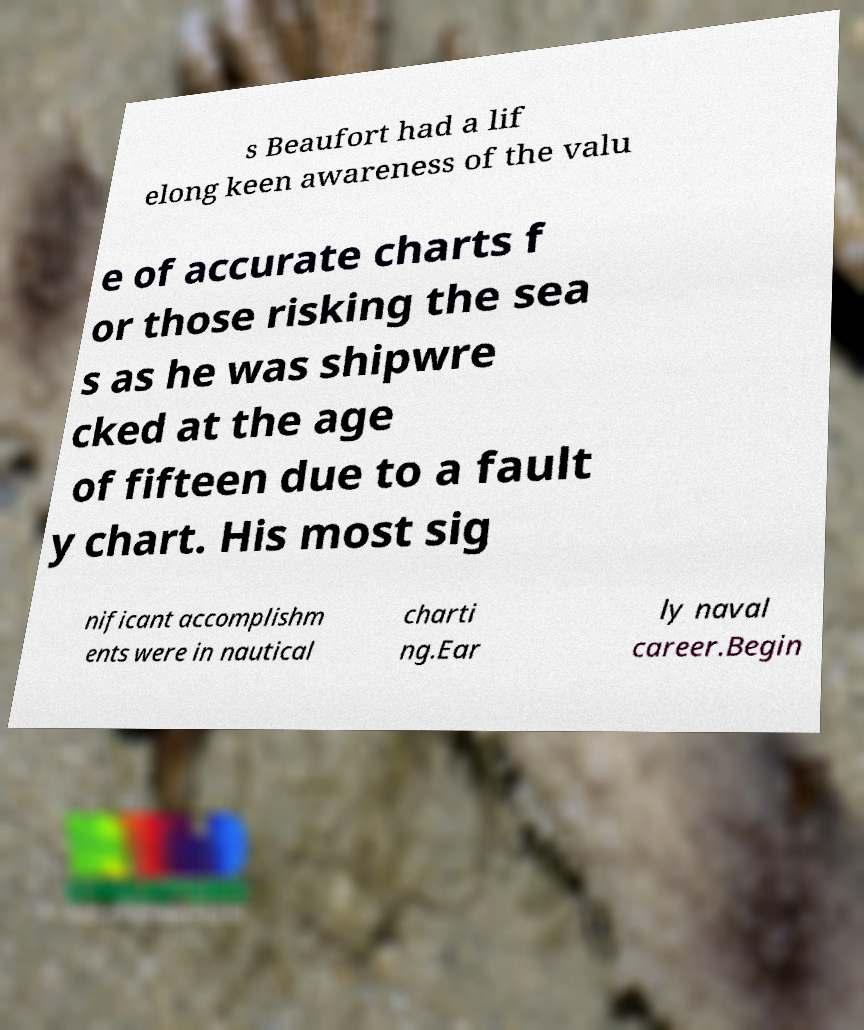Can you read and provide the text displayed in the image?This photo seems to have some interesting text. Can you extract and type it out for me? s Beaufort had a lif elong keen awareness of the valu e of accurate charts f or those risking the sea s as he was shipwre cked at the age of fifteen due to a fault y chart. His most sig nificant accomplishm ents were in nautical charti ng.Ear ly naval career.Begin 